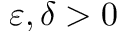<formula> <loc_0><loc_0><loc_500><loc_500>\varepsilon , \delta > 0</formula> 